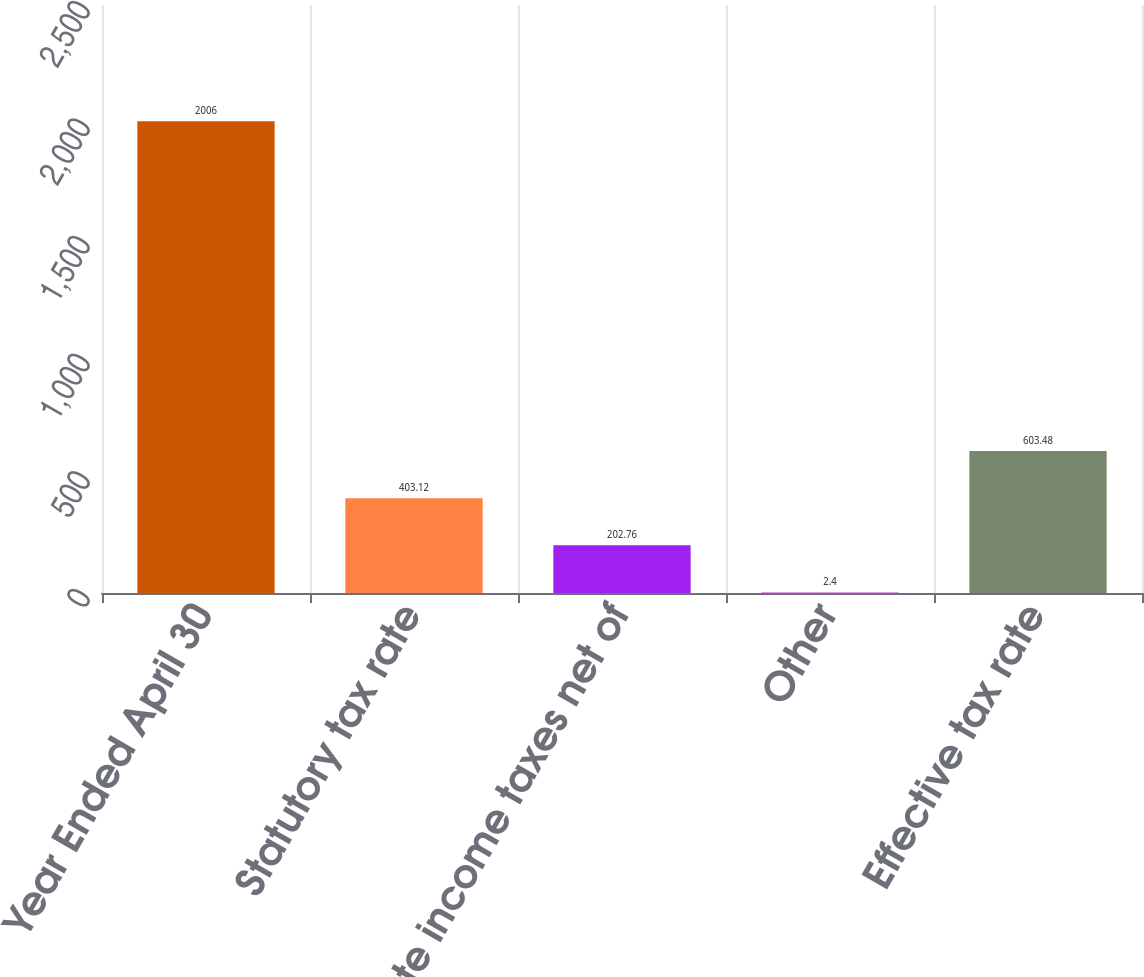Convert chart to OTSL. <chart><loc_0><loc_0><loc_500><loc_500><bar_chart><fcel>Year Ended April 30<fcel>Statutory tax rate<fcel>State income taxes net of<fcel>Other<fcel>Effective tax rate<nl><fcel>2006<fcel>403.12<fcel>202.76<fcel>2.4<fcel>603.48<nl></chart> 